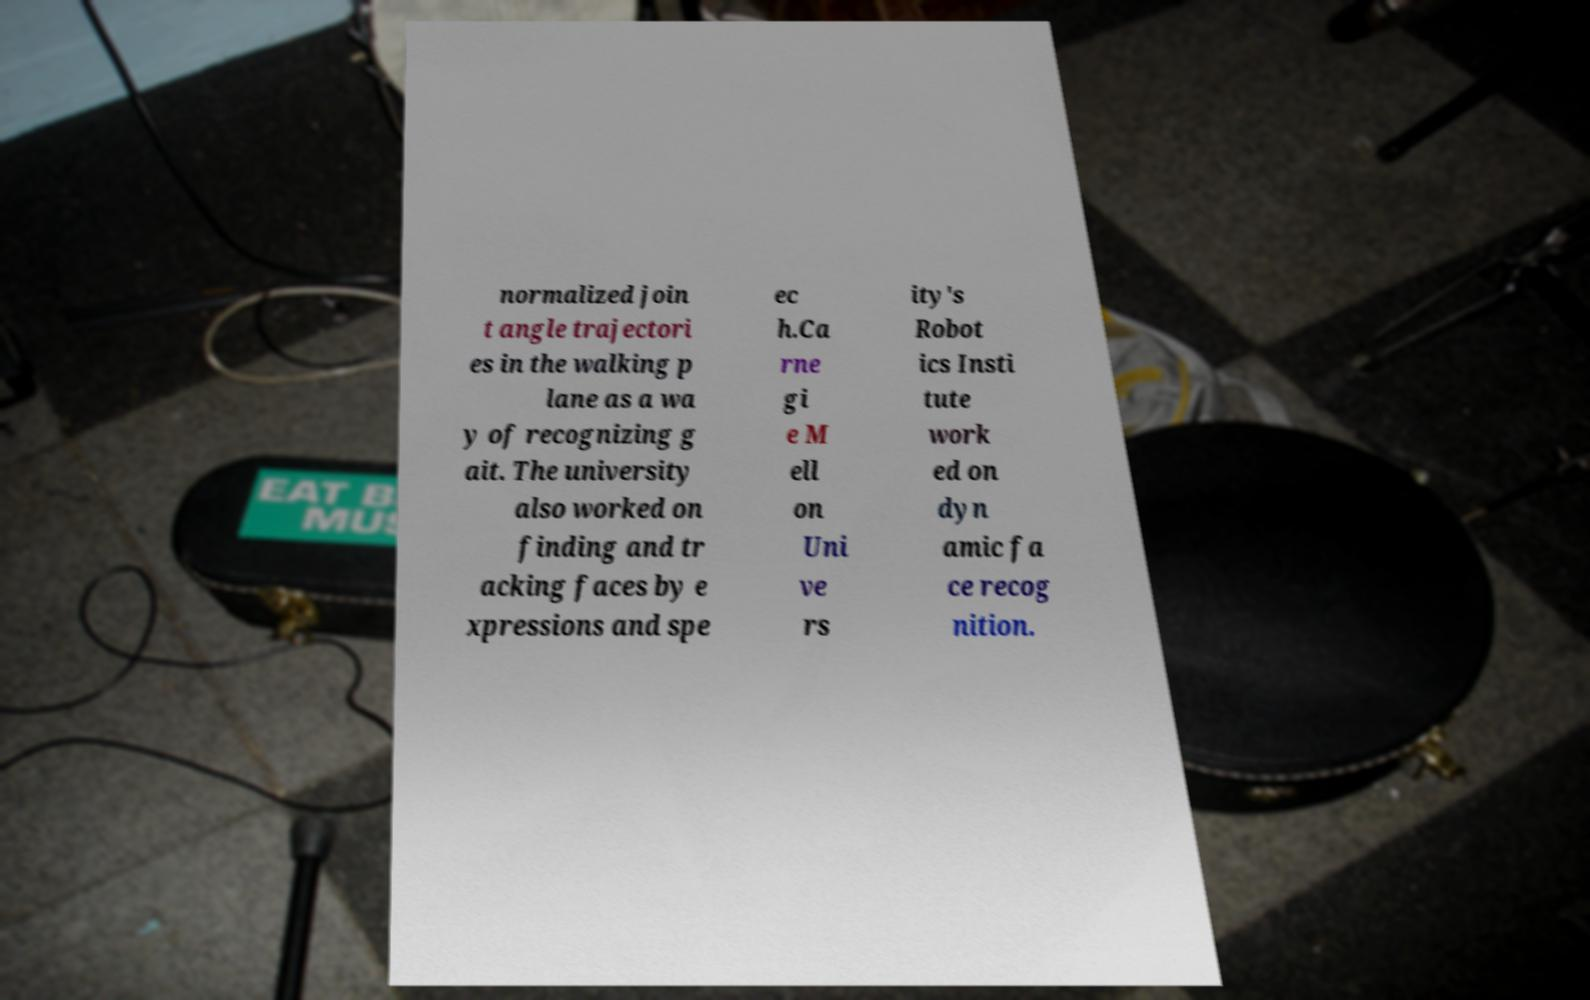There's text embedded in this image that I need extracted. Can you transcribe it verbatim? normalized join t angle trajectori es in the walking p lane as a wa y of recognizing g ait. The university also worked on finding and tr acking faces by e xpressions and spe ec h.Ca rne gi e M ell on Uni ve rs ity's Robot ics Insti tute work ed on dyn amic fa ce recog nition. 